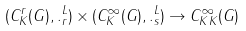<formula> <loc_0><loc_0><loc_500><loc_500>( C ^ { r } _ { K } ( G ) , \| . \| ^ { L } _ { r } ) \times ( C ^ { \infty } _ { K } ( G ) , \| . \| ^ { L } _ { s } ) \to C ^ { \infty } _ { K K } ( G )</formula> 